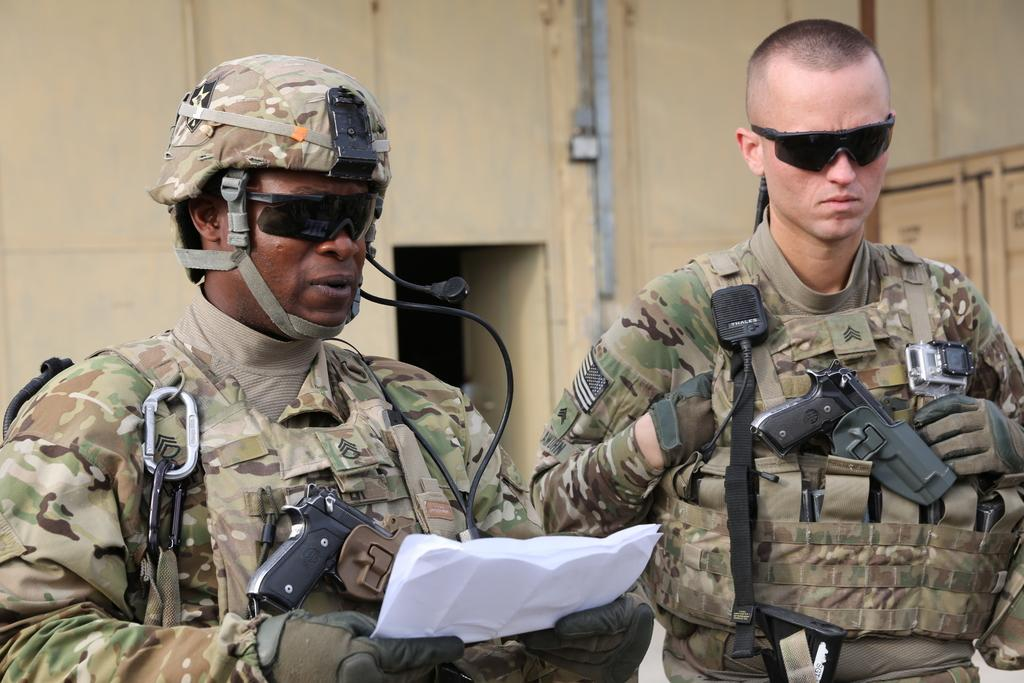How many people are in the image? There are two people in the image. What are the people wearing? Both people are wearing the same dress and spectacles. What might one of the people be doing with the papers they are holding? One person is holding some papers, which might suggest they are reading or working with them. Where is the bag located in the image? There is no bag present in the image. What is the tongue doing in the image? There is no tongue present in the image. 